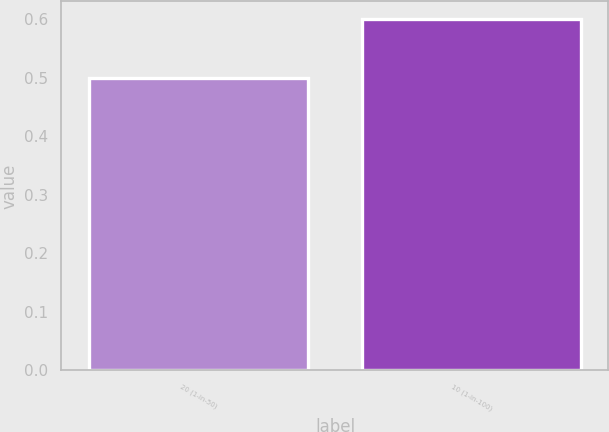<chart> <loc_0><loc_0><loc_500><loc_500><bar_chart><fcel>20 (1-in-50)<fcel>10 (1-in-100)<nl><fcel>0.5<fcel>0.6<nl></chart> 